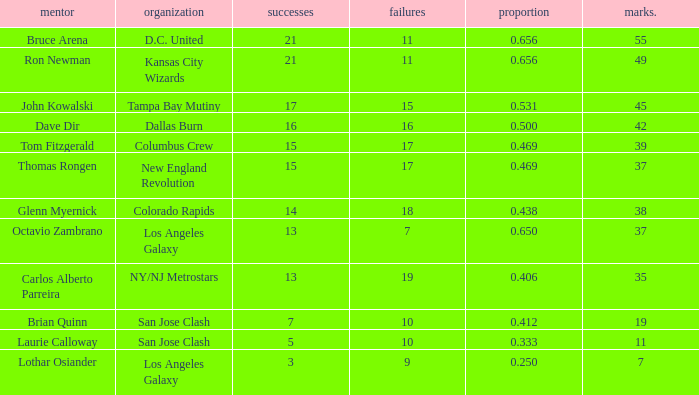What is the sum of points when Bruce Arena has 21 wins? 55.0. Write the full table. {'header': ['mentor', 'organization', 'successes', 'failures', 'proportion', 'marks.'], 'rows': [['Bruce Arena', 'D.C. United', '21', '11', '0.656', '55'], ['Ron Newman', 'Kansas City Wizards', '21', '11', '0.656', '49'], ['John Kowalski', 'Tampa Bay Mutiny', '17', '15', '0.531', '45'], ['Dave Dir', 'Dallas Burn', '16', '16', '0.500', '42'], ['Tom Fitzgerald', 'Columbus Crew', '15', '17', '0.469', '39'], ['Thomas Rongen', 'New England Revolution', '15', '17', '0.469', '37'], ['Glenn Myernick', 'Colorado Rapids', '14', '18', '0.438', '38'], ['Octavio Zambrano', 'Los Angeles Galaxy', '13', '7', '0.650', '37'], ['Carlos Alberto Parreira', 'NY/NJ Metrostars', '13', '19', '0.406', '35'], ['Brian Quinn', 'San Jose Clash', '7', '10', '0.412', '19'], ['Laurie Calloway', 'San Jose Clash', '5', '10', '0.333', '11'], ['Lothar Osiander', 'Los Angeles Galaxy', '3', '9', '0.250', '7']]} 